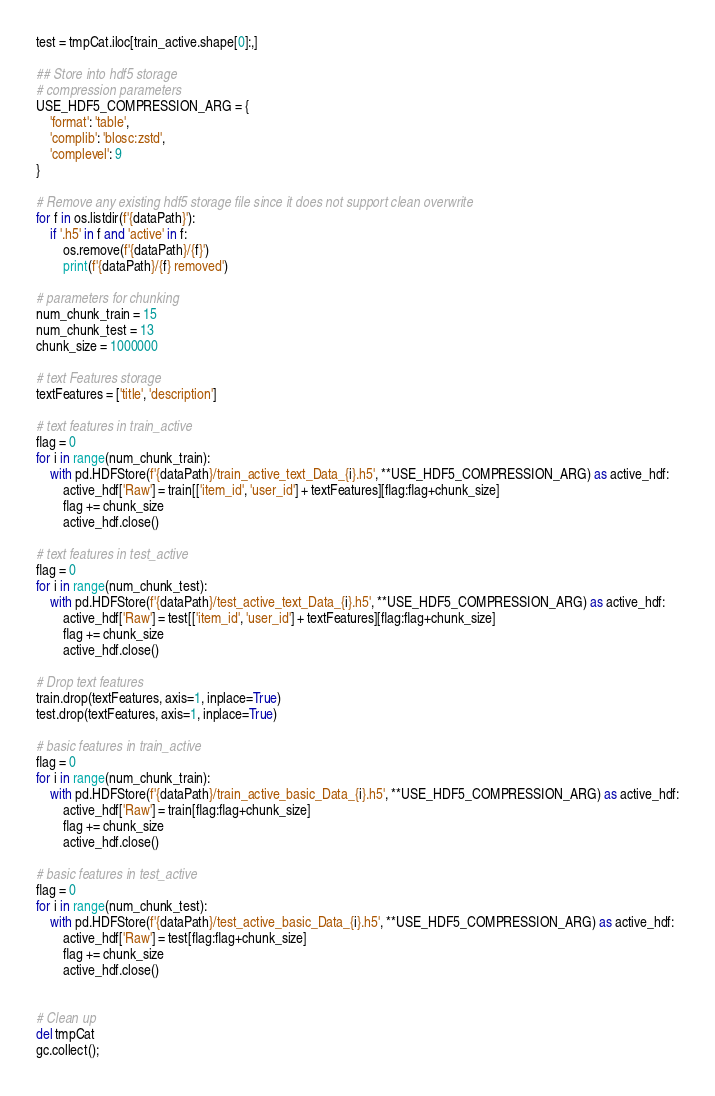Convert code to text. <code><loc_0><loc_0><loc_500><loc_500><_Python_>test = tmpCat.iloc[train_active.shape[0]:,]

## Store into hdf5 storage
# compression parameters
USE_HDF5_COMPRESSION_ARG = {
    'format': 'table', 
    'complib': 'blosc:zstd', 
    'complevel': 9
}

# Remove any existing hdf5 storage file since it does not support clean overwrite
for f in os.listdir(f'{dataPath}'): 
    if '.h5' in f and 'active' in f:
        os.remove(f'{dataPath}/{f}')
        print(f'{dataPath}/{f} removed')

# parameters for chunking
num_chunk_train = 15
num_chunk_test = 13
chunk_size = 1000000

# text Features storage
textFeatures = ['title', 'description']

# text features in train_active
flag = 0
for i in range(num_chunk_train):
    with pd.HDFStore(f'{dataPath}/train_active_text_Data_{i}.h5', **USE_HDF5_COMPRESSION_ARG) as active_hdf:
        active_hdf['Raw'] = train[['item_id', 'user_id'] + textFeatures][flag:flag+chunk_size]
        flag += chunk_size
        active_hdf.close()
      
# text features in test_active
flag = 0
for i in range(num_chunk_test):
    with pd.HDFStore(f'{dataPath}/test_active_text_Data_{i}.h5', **USE_HDF5_COMPRESSION_ARG) as active_hdf:
        active_hdf['Raw'] = test[['item_id', 'user_id'] + textFeatures][flag:flag+chunk_size]
        flag += chunk_size
        active_hdf.close()

# Drop text features
train.drop(textFeatures, axis=1, inplace=True)
test.drop(textFeatures, axis=1, inplace=True)

# basic features in train_active
flag = 0
for i in range(num_chunk_train):
    with pd.HDFStore(f'{dataPath}/train_active_basic_Data_{i}.h5', **USE_HDF5_COMPRESSION_ARG) as active_hdf:
        active_hdf['Raw'] = train[flag:flag+chunk_size]
        flag += chunk_size
        active_hdf.close()

# basic features in test_active
flag = 0
for i in range(num_chunk_test):
    with pd.HDFStore(f'{dataPath}/test_active_basic_Data_{i}.h5', **USE_HDF5_COMPRESSION_ARG) as active_hdf:
        active_hdf['Raw'] = test[flag:flag+chunk_size]
        flag += chunk_size
        active_hdf.close()


# Clean up
del tmpCat
gc.collect();
</code> 